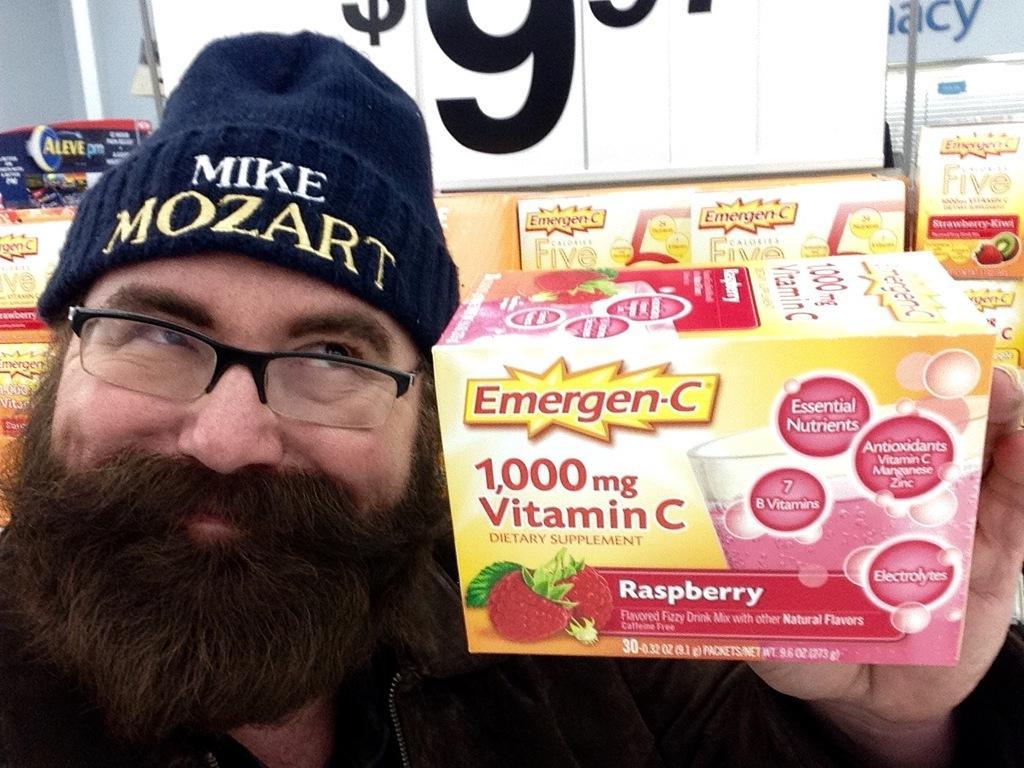Could you give a brief overview of what you see in this image? In this image there is a man showing the box. The man is holding the box with his hand. In the background there is a price tag and there are boxes below it. 